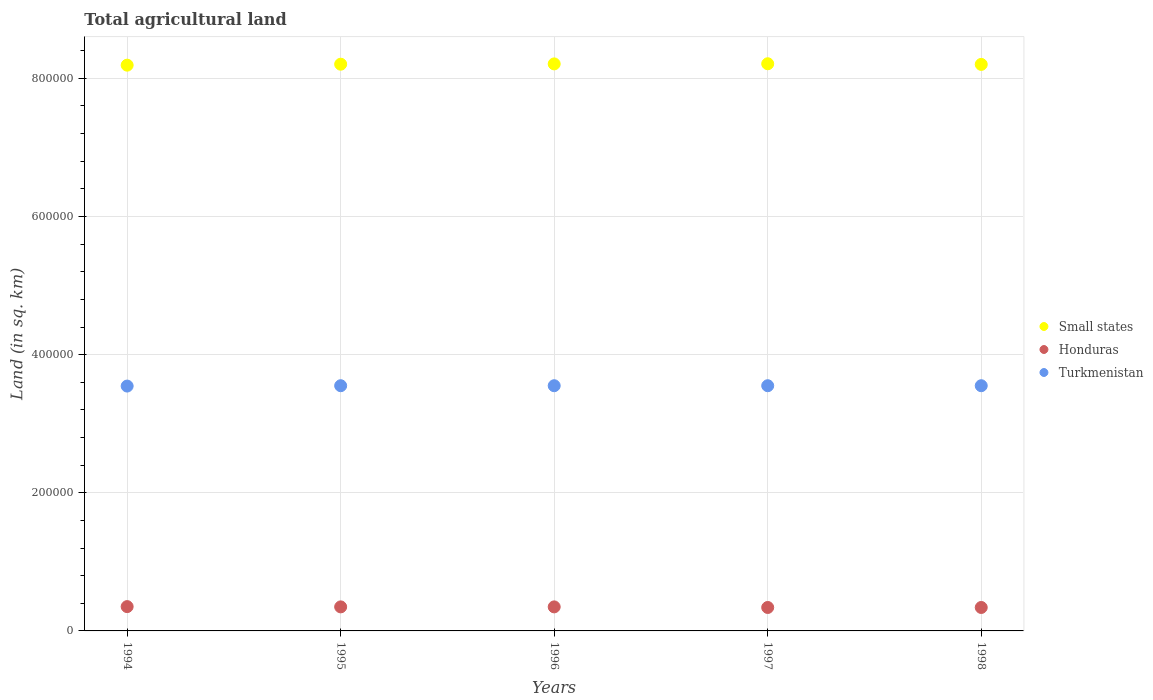Is the number of dotlines equal to the number of legend labels?
Your answer should be compact. Yes. What is the total agricultural land in Small states in 1995?
Provide a succinct answer. 8.20e+05. Across all years, what is the maximum total agricultural land in Turkmenistan?
Provide a succinct answer. 3.55e+05. Across all years, what is the minimum total agricultural land in Turkmenistan?
Provide a succinct answer. 3.54e+05. What is the total total agricultural land in Small states in the graph?
Provide a short and direct response. 4.10e+06. What is the difference between the total agricultural land in Honduras in 1994 and the total agricultural land in Small states in 1995?
Your answer should be compact. -7.85e+05. What is the average total agricultural land in Turkmenistan per year?
Keep it short and to the point. 3.55e+05. In the year 1994, what is the difference between the total agricultural land in Small states and total agricultural land in Turkmenistan?
Provide a short and direct response. 4.65e+05. In how many years, is the total agricultural land in Honduras greater than 80000 sq.km?
Ensure brevity in your answer.  0. What is the ratio of the total agricultural land in Small states in 1997 to that in 1998?
Offer a terse response. 1. Is the total agricultural land in Small states in 1995 less than that in 1996?
Make the answer very short. Yes. What is the difference between the highest and the second highest total agricultural land in Turkmenistan?
Your answer should be compact. 0. What is the difference between the highest and the lowest total agricultural land in Turkmenistan?
Your response must be concise. 500. In how many years, is the total agricultural land in Small states greater than the average total agricultural land in Small states taken over all years?
Make the answer very short. 3. Is it the case that in every year, the sum of the total agricultural land in Honduras and total agricultural land in Small states  is greater than the total agricultural land in Turkmenistan?
Provide a succinct answer. Yes. Does the total agricultural land in Honduras monotonically increase over the years?
Your answer should be very brief. No. Is the total agricultural land in Small states strictly greater than the total agricultural land in Turkmenistan over the years?
Ensure brevity in your answer.  Yes. Is the total agricultural land in Honduras strictly less than the total agricultural land in Turkmenistan over the years?
Your answer should be compact. Yes. How many dotlines are there?
Give a very brief answer. 3. Does the graph contain grids?
Your answer should be very brief. Yes. How many legend labels are there?
Provide a short and direct response. 3. How are the legend labels stacked?
Provide a short and direct response. Vertical. What is the title of the graph?
Make the answer very short. Total agricultural land. What is the label or title of the X-axis?
Your answer should be compact. Years. What is the label or title of the Y-axis?
Offer a very short reply. Land (in sq. km). What is the Land (in sq. km) in Small states in 1994?
Ensure brevity in your answer.  8.19e+05. What is the Land (in sq. km) in Honduras in 1994?
Your response must be concise. 3.52e+04. What is the Land (in sq. km) of Turkmenistan in 1994?
Give a very brief answer. 3.54e+05. What is the Land (in sq. km) of Small states in 1995?
Your response must be concise. 8.20e+05. What is the Land (in sq. km) of Honduras in 1995?
Offer a terse response. 3.48e+04. What is the Land (in sq. km) of Turkmenistan in 1995?
Provide a short and direct response. 3.55e+05. What is the Land (in sq. km) in Small states in 1996?
Provide a succinct answer. 8.21e+05. What is the Land (in sq. km) of Honduras in 1996?
Your response must be concise. 3.48e+04. What is the Land (in sq. km) of Turkmenistan in 1996?
Offer a very short reply. 3.55e+05. What is the Land (in sq. km) in Small states in 1997?
Keep it short and to the point. 8.21e+05. What is the Land (in sq. km) in Honduras in 1997?
Keep it short and to the point. 3.40e+04. What is the Land (in sq. km) of Turkmenistan in 1997?
Ensure brevity in your answer.  3.55e+05. What is the Land (in sq. km) in Small states in 1998?
Provide a short and direct response. 8.20e+05. What is the Land (in sq. km) in Honduras in 1998?
Provide a short and direct response. 3.40e+04. What is the Land (in sq. km) in Turkmenistan in 1998?
Offer a very short reply. 3.55e+05. Across all years, what is the maximum Land (in sq. km) in Small states?
Offer a terse response. 8.21e+05. Across all years, what is the maximum Land (in sq. km) in Honduras?
Provide a succinct answer. 3.52e+04. Across all years, what is the maximum Land (in sq. km) of Turkmenistan?
Your answer should be compact. 3.55e+05. Across all years, what is the minimum Land (in sq. km) in Small states?
Keep it short and to the point. 8.19e+05. Across all years, what is the minimum Land (in sq. km) in Honduras?
Offer a terse response. 3.40e+04. Across all years, what is the minimum Land (in sq. km) in Turkmenistan?
Provide a succinct answer. 3.54e+05. What is the total Land (in sq. km) in Small states in the graph?
Provide a short and direct response. 4.10e+06. What is the total Land (in sq. km) of Honduras in the graph?
Give a very brief answer. 1.73e+05. What is the total Land (in sq. km) of Turkmenistan in the graph?
Ensure brevity in your answer.  1.77e+06. What is the difference between the Land (in sq. km) of Small states in 1994 and that in 1995?
Give a very brief answer. -1395. What is the difference between the Land (in sq. km) in Turkmenistan in 1994 and that in 1995?
Give a very brief answer. -500. What is the difference between the Land (in sq. km) of Small states in 1994 and that in 1996?
Keep it short and to the point. -1829. What is the difference between the Land (in sq. km) of Turkmenistan in 1994 and that in 1996?
Your answer should be very brief. -500. What is the difference between the Land (in sq. km) of Small states in 1994 and that in 1997?
Provide a short and direct response. -2025. What is the difference between the Land (in sq. km) in Honduras in 1994 and that in 1997?
Ensure brevity in your answer.  1250. What is the difference between the Land (in sq. km) in Turkmenistan in 1994 and that in 1997?
Ensure brevity in your answer.  -500. What is the difference between the Land (in sq. km) of Small states in 1994 and that in 1998?
Provide a short and direct response. -1100. What is the difference between the Land (in sq. km) of Honduras in 1994 and that in 1998?
Your answer should be compact. 1250. What is the difference between the Land (in sq. km) in Turkmenistan in 1994 and that in 1998?
Offer a terse response. -500. What is the difference between the Land (in sq. km) of Small states in 1995 and that in 1996?
Provide a succinct answer. -434. What is the difference between the Land (in sq. km) in Small states in 1995 and that in 1997?
Your response must be concise. -630. What is the difference between the Land (in sq. km) of Honduras in 1995 and that in 1997?
Ensure brevity in your answer.  850. What is the difference between the Land (in sq. km) of Small states in 1995 and that in 1998?
Provide a succinct answer. 295. What is the difference between the Land (in sq. km) in Honduras in 1995 and that in 1998?
Make the answer very short. 850. What is the difference between the Land (in sq. km) of Turkmenistan in 1995 and that in 1998?
Your answer should be very brief. 0. What is the difference between the Land (in sq. km) in Small states in 1996 and that in 1997?
Ensure brevity in your answer.  -196. What is the difference between the Land (in sq. km) of Honduras in 1996 and that in 1997?
Keep it short and to the point. 850. What is the difference between the Land (in sq. km) in Turkmenistan in 1996 and that in 1997?
Your response must be concise. 0. What is the difference between the Land (in sq. km) in Small states in 1996 and that in 1998?
Offer a terse response. 729. What is the difference between the Land (in sq. km) of Honduras in 1996 and that in 1998?
Provide a succinct answer. 850. What is the difference between the Land (in sq. km) in Turkmenistan in 1996 and that in 1998?
Offer a terse response. 0. What is the difference between the Land (in sq. km) in Small states in 1997 and that in 1998?
Give a very brief answer. 925. What is the difference between the Land (in sq. km) in Honduras in 1997 and that in 1998?
Offer a terse response. 0. What is the difference between the Land (in sq. km) in Turkmenistan in 1997 and that in 1998?
Your answer should be very brief. 0. What is the difference between the Land (in sq. km) of Small states in 1994 and the Land (in sq. km) of Honduras in 1995?
Offer a very short reply. 7.84e+05. What is the difference between the Land (in sq. km) in Small states in 1994 and the Land (in sq. km) in Turkmenistan in 1995?
Offer a very short reply. 4.64e+05. What is the difference between the Land (in sq. km) of Honduras in 1994 and the Land (in sq. km) of Turkmenistan in 1995?
Ensure brevity in your answer.  -3.20e+05. What is the difference between the Land (in sq. km) in Small states in 1994 and the Land (in sq. km) in Honduras in 1996?
Your response must be concise. 7.84e+05. What is the difference between the Land (in sq. km) in Small states in 1994 and the Land (in sq. km) in Turkmenistan in 1996?
Offer a terse response. 4.64e+05. What is the difference between the Land (in sq. km) in Honduras in 1994 and the Land (in sq. km) in Turkmenistan in 1996?
Your response must be concise. -3.20e+05. What is the difference between the Land (in sq. km) of Small states in 1994 and the Land (in sq. km) of Honduras in 1997?
Your answer should be compact. 7.85e+05. What is the difference between the Land (in sq. km) of Small states in 1994 and the Land (in sq. km) of Turkmenistan in 1997?
Give a very brief answer. 4.64e+05. What is the difference between the Land (in sq. km) in Honduras in 1994 and the Land (in sq. km) in Turkmenistan in 1997?
Offer a terse response. -3.20e+05. What is the difference between the Land (in sq. km) of Small states in 1994 and the Land (in sq. km) of Honduras in 1998?
Keep it short and to the point. 7.85e+05. What is the difference between the Land (in sq. km) of Small states in 1994 and the Land (in sq. km) of Turkmenistan in 1998?
Keep it short and to the point. 4.64e+05. What is the difference between the Land (in sq. km) of Honduras in 1994 and the Land (in sq. km) of Turkmenistan in 1998?
Provide a succinct answer. -3.20e+05. What is the difference between the Land (in sq. km) in Small states in 1995 and the Land (in sq. km) in Honduras in 1996?
Your answer should be very brief. 7.86e+05. What is the difference between the Land (in sq. km) in Small states in 1995 and the Land (in sq. km) in Turkmenistan in 1996?
Ensure brevity in your answer.  4.65e+05. What is the difference between the Land (in sq. km) of Honduras in 1995 and the Land (in sq. km) of Turkmenistan in 1996?
Offer a terse response. -3.20e+05. What is the difference between the Land (in sq. km) in Small states in 1995 and the Land (in sq. km) in Honduras in 1997?
Your response must be concise. 7.87e+05. What is the difference between the Land (in sq. km) in Small states in 1995 and the Land (in sq. km) in Turkmenistan in 1997?
Give a very brief answer. 4.65e+05. What is the difference between the Land (in sq. km) in Honduras in 1995 and the Land (in sq. km) in Turkmenistan in 1997?
Offer a terse response. -3.20e+05. What is the difference between the Land (in sq. km) in Small states in 1995 and the Land (in sq. km) in Honduras in 1998?
Offer a terse response. 7.87e+05. What is the difference between the Land (in sq. km) in Small states in 1995 and the Land (in sq. km) in Turkmenistan in 1998?
Your answer should be very brief. 4.65e+05. What is the difference between the Land (in sq. km) of Honduras in 1995 and the Land (in sq. km) of Turkmenistan in 1998?
Make the answer very short. -3.20e+05. What is the difference between the Land (in sq. km) in Small states in 1996 and the Land (in sq. km) in Honduras in 1997?
Your answer should be very brief. 7.87e+05. What is the difference between the Land (in sq. km) of Small states in 1996 and the Land (in sq. km) of Turkmenistan in 1997?
Make the answer very short. 4.66e+05. What is the difference between the Land (in sq. km) of Honduras in 1996 and the Land (in sq. km) of Turkmenistan in 1997?
Your answer should be very brief. -3.20e+05. What is the difference between the Land (in sq. km) in Small states in 1996 and the Land (in sq. km) in Honduras in 1998?
Your answer should be compact. 7.87e+05. What is the difference between the Land (in sq. km) in Small states in 1996 and the Land (in sq. km) in Turkmenistan in 1998?
Provide a succinct answer. 4.66e+05. What is the difference between the Land (in sq. km) of Honduras in 1996 and the Land (in sq. km) of Turkmenistan in 1998?
Your answer should be compact. -3.20e+05. What is the difference between the Land (in sq. km) in Small states in 1997 and the Land (in sq. km) in Honduras in 1998?
Your answer should be compact. 7.87e+05. What is the difference between the Land (in sq. km) of Small states in 1997 and the Land (in sq. km) of Turkmenistan in 1998?
Provide a short and direct response. 4.66e+05. What is the difference between the Land (in sq. km) of Honduras in 1997 and the Land (in sq. km) of Turkmenistan in 1998?
Your answer should be very brief. -3.21e+05. What is the average Land (in sq. km) in Small states per year?
Keep it short and to the point. 8.20e+05. What is the average Land (in sq. km) in Honduras per year?
Offer a terse response. 3.45e+04. What is the average Land (in sq. km) in Turkmenistan per year?
Your answer should be compact. 3.55e+05. In the year 1994, what is the difference between the Land (in sq. km) in Small states and Land (in sq. km) in Honduras?
Ensure brevity in your answer.  7.84e+05. In the year 1994, what is the difference between the Land (in sq. km) in Small states and Land (in sq. km) in Turkmenistan?
Offer a very short reply. 4.65e+05. In the year 1994, what is the difference between the Land (in sq. km) of Honduras and Land (in sq. km) of Turkmenistan?
Your response must be concise. -3.19e+05. In the year 1995, what is the difference between the Land (in sq. km) of Small states and Land (in sq. km) of Honduras?
Your response must be concise. 7.86e+05. In the year 1995, what is the difference between the Land (in sq. km) of Small states and Land (in sq. km) of Turkmenistan?
Your response must be concise. 4.65e+05. In the year 1995, what is the difference between the Land (in sq. km) in Honduras and Land (in sq. km) in Turkmenistan?
Make the answer very short. -3.20e+05. In the year 1996, what is the difference between the Land (in sq. km) of Small states and Land (in sq. km) of Honduras?
Provide a succinct answer. 7.86e+05. In the year 1996, what is the difference between the Land (in sq. km) in Small states and Land (in sq. km) in Turkmenistan?
Offer a very short reply. 4.66e+05. In the year 1996, what is the difference between the Land (in sq. km) in Honduras and Land (in sq. km) in Turkmenistan?
Ensure brevity in your answer.  -3.20e+05. In the year 1997, what is the difference between the Land (in sq. km) in Small states and Land (in sq. km) in Honduras?
Your answer should be compact. 7.87e+05. In the year 1997, what is the difference between the Land (in sq. km) of Small states and Land (in sq. km) of Turkmenistan?
Give a very brief answer. 4.66e+05. In the year 1997, what is the difference between the Land (in sq. km) in Honduras and Land (in sq. km) in Turkmenistan?
Provide a succinct answer. -3.21e+05. In the year 1998, what is the difference between the Land (in sq. km) in Small states and Land (in sq. km) in Honduras?
Your answer should be very brief. 7.86e+05. In the year 1998, what is the difference between the Land (in sq. km) in Small states and Land (in sq. km) in Turkmenistan?
Provide a short and direct response. 4.65e+05. In the year 1998, what is the difference between the Land (in sq. km) of Honduras and Land (in sq. km) of Turkmenistan?
Give a very brief answer. -3.21e+05. What is the ratio of the Land (in sq. km) in Small states in 1994 to that in 1995?
Ensure brevity in your answer.  1. What is the ratio of the Land (in sq. km) in Honduras in 1994 to that in 1995?
Keep it short and to the point. 1.01. What is the ratio of the Land (in sq. km) in Honduras in 1994 to that in 1996?
Offer a terse response. 1.01. What is the ratio of the Land (in sq. km) in Turkmenistan in 1994 to that in 1996?
Ensure brevity in your answer.  1. What is the ratio of the Land (in sq. km) of Honduras in 1994 to that in 1997?
Your response must be concise. 1.04. What is the ratio of the Land (in sq. km) of Turkmenistan in 1994 to that in 1997?
Offer a terse response. 1. What is the ratio of the Land (in sq. km) of Honduras in 1994 to that in 1998?
Your answer should be compact. 1.04. What is the ratio of the Land (in sq. km) in Turkmenistan in 1994 to that in 1998?
Offer a terse response. 1. What is the ratio of the Land (in sq. km) in Small states in 1995 to that in 1996?
Your response must be concise. 1. What is the ratio of the Land (in sq. km) of Honduras in 1995 to that in 1996?
Ensure brevity in your answer.  1. What is the ratio of the Land (in sq. km) of Turkmenistan in 1995 to that in 1996?
Keep it short and to the point. 1. What is the ratio of the Land (in sq. km) of Small states in 1995 to that in 1997?
Give a very brief answer. 1. What is the ratio of the Land (in sq. km) in Honduras in 1995 to that in 1997?
Offer a terse response. 1.02. What is the ratio of the Land (in sq. km) in Turkmenistan in 1995 to that in 1998?
Your response must be concise. 1. What is the ratio of the Land (in sq. km) of Small states in 1996 to that in 1998?
Offer a terse response. 1. What is the ratio of the Land (in sq. km) in Turkmenistan in 1996 to that in 1998?
Keep it short and to the point. 1. What is the ratio of the Land (in sq. km) in Small states in 1997 to that in 1998?
Your response must be concise. 1. What is the difference between the highest and the second highest Land (in sq. km) in Small states?
Your answer should be compact. 196. What is the difference between the highest and the second highest Land (in sq. km) in Honduras?
Make the answer very short. 400. What is the difference between the highest and the second highest Land (in sq. km) in Turkmenistan?
Offer a very short reply. 0. What is the difference between the highest and the lowest Land (in sq. km) of Small states?
Ensure brevity in your answer.  2025. What is the difference between the highest and the lowest Land (in sq. km) of Honduras?
Your answer should be compact. 1250. 